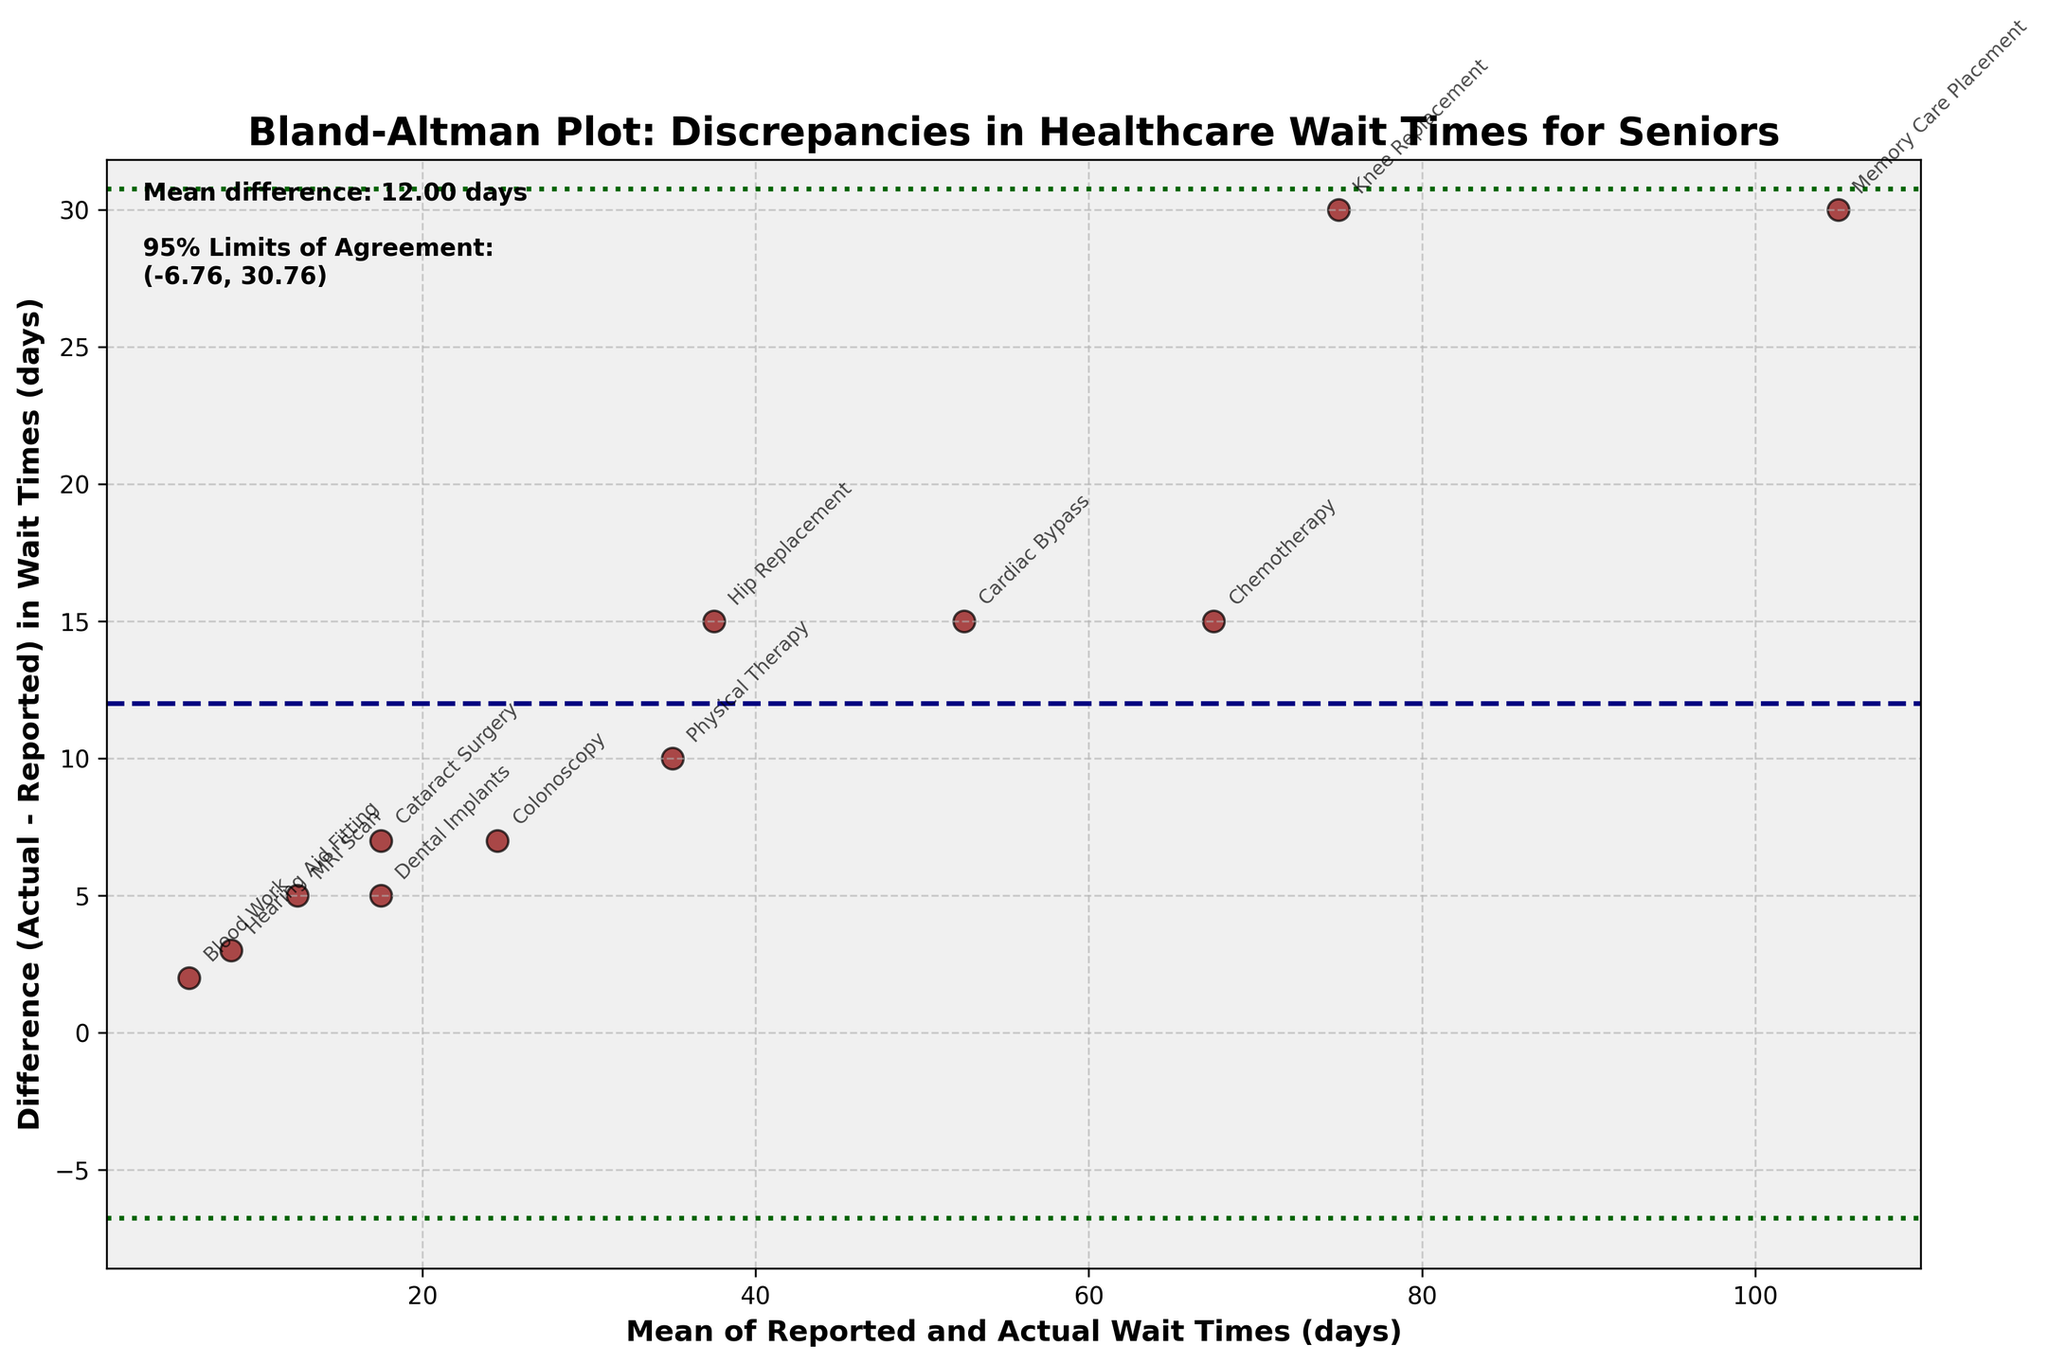what is the title of the plot? The title is usually found at the top of the plot. Look at the top to see the large, bold text which typically denotes the title.
Answer: Bland-Altman Plot: Discrepancies in Healthcare Wait Times for Seniors What is the mean difference in wait times? The mean difference is indicated by the horizontal dashed line in the plot, which is also labeled in the top left corner.
Answer: 10 days What are the 95% limits of agreement for the differences in wait times? The 95% limits of agreement are marked by the dotted lines, and the values are labeled in the top left corner of the plot.
Answer: (-1.18, 21.19) days Which healthcare service has the largest discrepancy in recorded and actual wait times? Look for the data point that is the farthest away from the x-axis (largest vertical displacement). Check the annotation next to this point.
Answer: Chemotherapy Which healthcare service has the smallest absolute discrepancy between the reported and actual wait times? Identify the data point that is closest to the x-axis (smallest vertical displacement). Check the annotation next to this point.
Answer: Blood Work How many data points are there in the plot? Each healthcare service is represented by a data point. Count the unique healthcare service annotations on the plot.
Answer: 12 For which healthcare service is the reported wait time least accurate compared to the actual wait time? Accuracy of the reported wait time can be judged by the magnitude of the difference. The point that is farthest from the x-axis represents the least accurate report.
Answer: Chemotherapy How many healthcare services have a difference (Actual - Reported) above the mean difference line? Count the number of data points that are above the horizontal dashed line representing the mean difference.
Answer: 6 Which data point shows that the actual wait time is 50% higher than the reported wait time? A 50% higher actual wait time means the difference between actual and reported times is 50% of the reported time. Look for the point where (Actual - Reported) = Reported * 0.5.
Answer: Colonoscopy Are there any services where the actual wait time is exactly 50% more than the reported wait time? Verify if the plot has any data point situated where (Actual - Reported) equals exactly 50% of the reported value.
Answer: No 